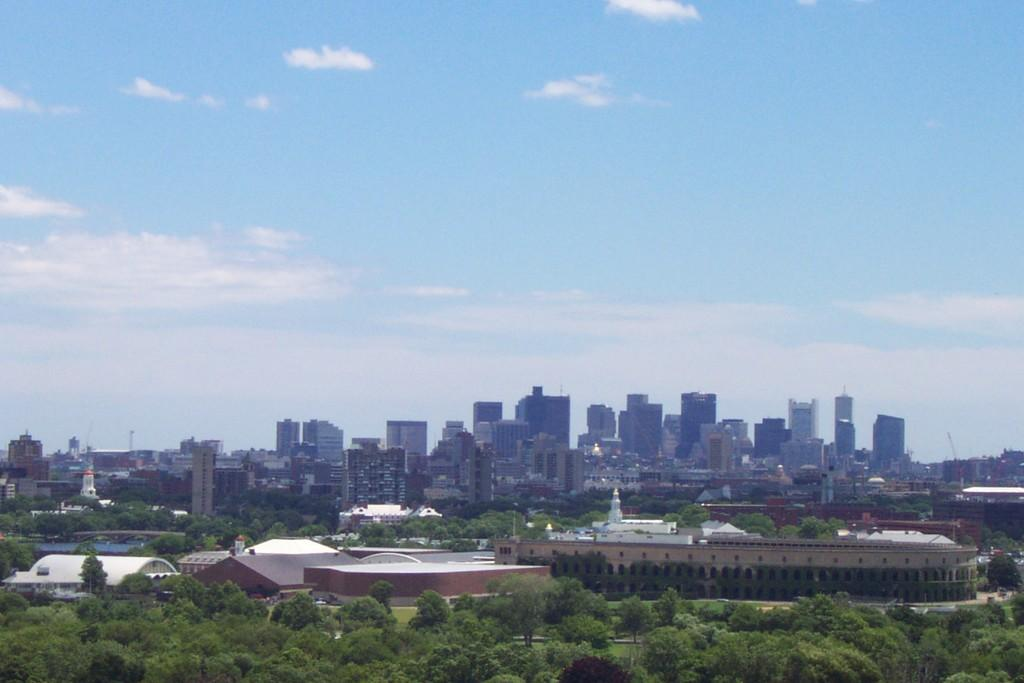What type of location is depicted in the image? The image contains a view of a city. What structures can be seen in the city? There are buildings in the image. Are there any natural elements present in the city? Yes, there are trees in the image. What can be seen in the distance in the image? The sky is visible in the background of the image. What type of belief can be seen in the mouth of the person in the image? There is no person present in the image, and therefore no mouth or belief to observe. 